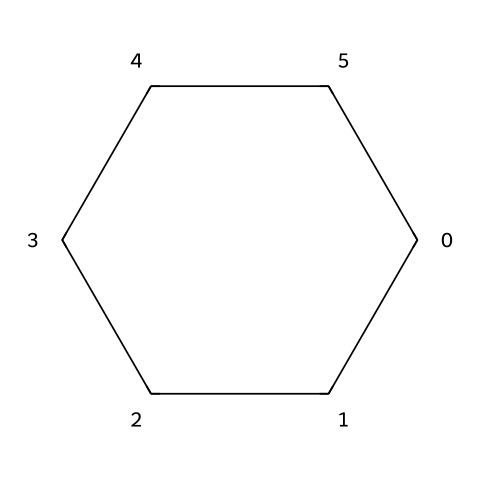What is the molecular formula of cyclohexane? The SMILES representation "C1CCCCC1" indicates a cycloalkane with six carbon atoms connected in a ring, each corresponding to two hydrogens (C6H12).
Answer: C6H12 How many carbon atoms are in cyclohexane? The structure "C1CCCCC1" shows a continuous chain of six carbon atoms, which reveals that there are six carbon atoms in total.
Answer: six Does cyclohexane contain any double bonds? The structure "C1CCCCC1" demonstrates that all carbon atoms are connected by single bonds only, indicating that there are no double bonds present.
Answer: no What type of hybridization do the carbon atoms in cyclohexane exhibit? In the cyclohexane structure "C1CCCCC1," each carbon atom forms four bonds using sp3 hybridization due to the tetrahedral geometry around each carbon.
Answer: sp3 Is cyclohexane a saturated or unsaturated hydrocarbon? Based on the structure "C1CCCCC1," all bonds are single, which qualifies cyclohexane as a saturated hydrocarbon with no double or triple bonds.
Answer: saturated What is the shape of the cyclohexane molecule? The SMILES notation "C1CCCCC1" corresponds to a cyclic structure, specifically a chair conformation, which provides a stable and minimized steric hindrance between hydrogen atoms.
Answer: chair What kind of chemical is cyclohexane categorized as? Given the structure "C1CCCCC1," cyclohexane is classified under the category of cycloalkanes, which are aliphatic hydrocarbons featuring a ring structure.
Answer: cycloalkane 